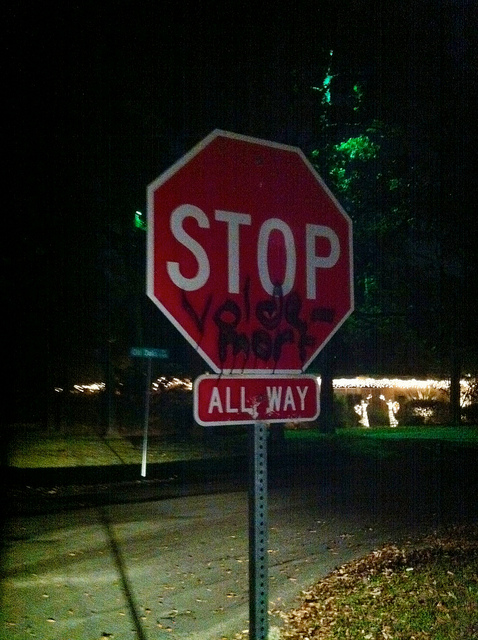Identify the text displayed in this image. STOP ALL WAY more volde 